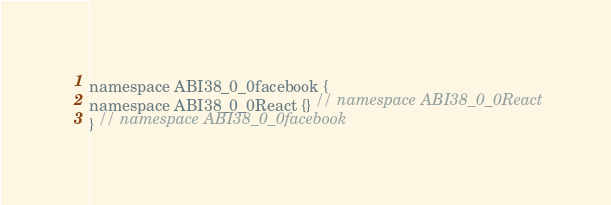Convert code to text. <code><loc_0><loc_0><loc_500><loc_500><_ObjectiveC_>
namespace ABI38_0_0facebook {
namespace ABI38_0_0React {} // namespace ABI38_0_0React
} // namespace ABI38_0_0facebook
</code> 